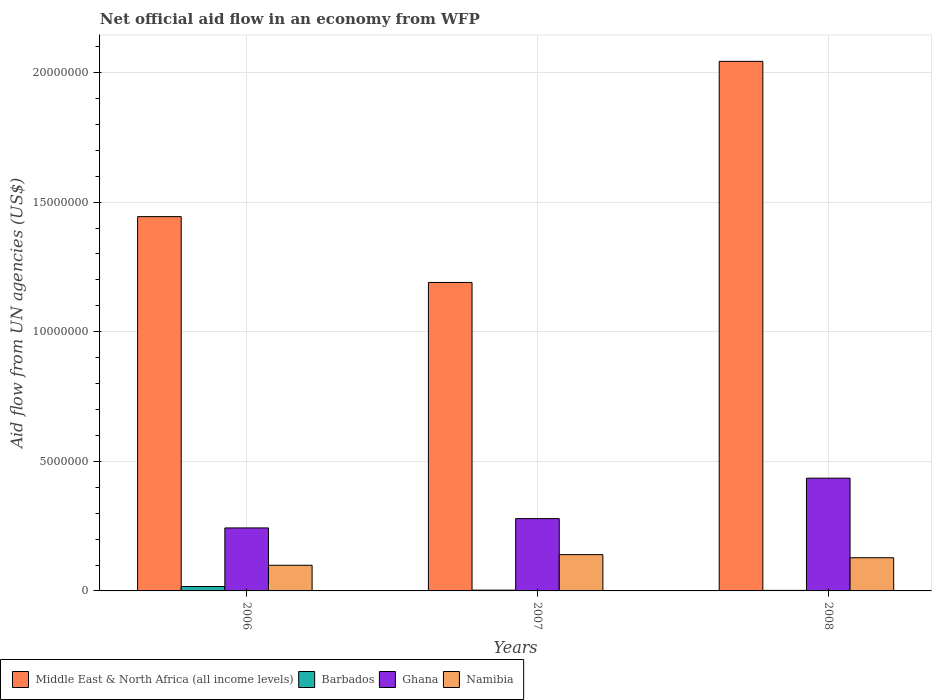How many different coloured bars are there?
Make the answer very short. 4. Are the number of bars per tick equal to the number of legend labels?
Provide a short and direct response. Yes. In how many cases, is the number of bars for a given year not equal to the number of legend labels?
Provide a short and direct response. 0. What is the net official aid flow in Middle East & North Africa (all income levels) in 2006?
Make the answer very short. 1.44e+07. Across all years, what is the maximum net official aid flow in Namibia?
Keep it short and to the point. 1.40e+06. Across all years, what is the minimum net official aid flow in Namibia?
Provide a short and direct response. 9.90e+05. In which year was the net official aid flow in Namibia maximum?
Offer a terse response. 2007. What is the total net official aid flow in Middle East & North Africa (all income levels) in the graph?
Your answer should be very brief. 4.68e+07. What is the difference between the net official aid flow in Namibia in 2007 and the net official aid flow in Middle East & North Africa (all income levels) in 2006?
Your answer should be very brief. -1.30e+07. What is the average net official aid flow in Barbados per year?
Your answer should be very brief. 7.33e+04. In the year 2006, what is the difference between the net official aid flow in Namibia and net official aid flow in Ghana?
Offer a very short reply. -1.44e+06. What is the ratio of the net official aid flow in Middle East & North Africa (all income levels) in 2006 to that in 2007?
Your answer should be compact. 1.21. Is the difference between the net official aid flow in Namibia in 2007 and 2008 greater than the difference between the net official aid flow in Ghana in 2007 and 2008?
Keep it short and to the point. Yes. What is the difference between the highest and the second highest net official aid flow in Ghana?
Your answer should be very brief. 1.56e+06. In how many years, is the net official aid flow in Middle East & North Africa (all income levels) greater than the average net official aid flow in Middle East & North Africa (all income levels) taken over all years?
Ensure brevity in your answer.  1. Is the sum of the net official aid flow in Namibia in 2006 and 2007 greater than the maximum net official aid flow in Barbados across all years?
Offer a very short reply. Yes. Is it the case that in every year, the sum of the net official aid flow in Barbados and net official aid flow in Namibia is greater than the sum of net official aid flow in Middle East & North Africa (all income levels) and net official aid flow in Ghana?
Keep it short and to the point. No. What does the 2nd bar from the left in 2008 represents?
Make the answer very short. Barbados. What does the 1st bar from the right in 2006 represents?
Ensure brevity in your answer.  Namibia. Are all the bars in the graph horizontal?
Ensure brevity in your answer.  No. How many years are there in the graph?
Offer a terse response. 3. What is the difference between two consecutive major ticks on the Y-axis?
Offer a very short reply. 5.00e+06. Are the values on the major ticks of Y-axis written in scientific E-notation?
Make the answer very short. No. Does the graph contain any zero values?
Give a very brief answer. No. Where does the legend appear in the graph?
Your answer should be very brief. Bottom left. How many legend labels are there?
Make the answer very short. 4. How are the legend labels stacked?
Ensure brevity in your answer.  Horizontal. What is the title of the graph?
Make the answer very short. Net official aid flow in an economy from WFP. What is the label or title of the Y-axis?
Keep it short and to the point. Aid flow from UN agencies (US$). What is the Aid flow from UN agencies (US$) in Middle East & North Africa (all income levels) in 2006?
Ensure brevity in your answer.  1.44e+07. What is the Aid flow from UN agencies (US$) in Ghana in 2006?
Provide a short and direct response. 2.43e+06. What is the Aid flow from UN agencies (US$) in Namibia in 2006?
Your answer should be compact. 9.90e+05. What is the Aid flow from UN agencies (US$) of Middle East & North Africa (all income levels) in 2007?
Provide a succinct answer. 1.19e+07. What is the Aid flow from UN agencies (US$) of Barbados in 2007?
Your answer should be very brief. 3.00e+04. What is the Aid flow from UN agencies (US$) of Ghana in 2007?
Offer a very short reply. 2.79e+06. What is the Aid flow from UN agencies (US$) of Namibia in 2007?
Give a very brief answer. 1.40e+06. What is the Aid flow from UN agencies (US$) in Middle East & North Africa (all income levels) in 2008?
Provide a succinct answer. 2.04e+07. What is the Aid flow from UN agencies (US$) in Ghana in 2008?
Your response must be concise. 4.35e+06. What is the Aid flow from UN agencies (US$) in Namibia in 2008?
Keep it short and to the point. 1.28e+06. Across all years, what is the maximum Aid flow from UN agencies (US$) of Middle East & North Africa (all income levels)?
Your answer should be very brief. 2.04e+07. Across all years, what is the maximum Aid flow from UN agencies (US$) of Barbados?
Make the answer very short. 1.70e+05. Across all years, what is the maximum Aid flow from UN agencies (US$) of Ghana?
Make the answer very short. 4.35e+06. Across all years, what is the maximum Aid flow from UN agencies (US$) of Namibia?
Give a very brief answer. 1.40e+06. Across all years, what is the minimum Aid flow from UN agencies (US$) of Middle East & North Africa (all income levels)?
Keep it short and to the point. 1.19e+07. Across all years, what is the minimum Aid flow from UN agencies (US$) in Ghana?
Provide a short and direct response. 2.43e+06. Across all years, what is the minimum Aid flow from UN agencies (US$) in Namibia?
Your answer should be very brief. 9.90e+05. What is the total Aid flow from UN agencies (US$) of Middle East & North Africa (all income levels) in the graph?
Your response must be concise. 4.68e+07. What is the total Aid flow from UN agencies (US$) of Ghana in the graph?
Offer a terse response. 9.57e+06. What is the total Aid flow from UN agencies (US$) of Namibia in the graph?
Provide a succinct answer. 3.67e+06. What is the difference between the Aid flow from UN agencies (US$) in Middle East & North Africa (all income levels) in 2006 and that in 2007?
Your answer should be very brief. 2.54e+06. What is the difference between the Aid flow from UN agencies (US$) in Ghana in 2006 and that in 2007?
Your answer should be compact. -3.60e+05. What is the difference between the Aid flow from UN agencies (US$) of Namibia in 2006 and that in 2007?
Provide a short and direct response. -4.10e+05. What is the difference between the Aid flow from UN agencies (US$) of Middle East & North Africa (all income levels) in 2006 and that in 2008?
Offer a very short reply. -5.99e+06. What is the difference between the Aid flow from UN agencies (US$) of Barbados in 2006 and that in 2008?
Ensure brevity in your answer.  1.50e+05. What is the difference between the Aid flow from UN agencies (US$) in Ghana in 2006 and that in 2008?
Your answer should be compact. -1.92e+06. What is the difference between the Aid flow from UN agencies (US$) in Namibia in 2006 and that in 2008?
Your answer should be very brief. -2.90e+05. What is the difference between the Aid flow from UN agencies (US$) in Middle East & North Africa (all income levels) in 2007 and that in 2008?
Give a very brief answer. -8.53e+06. What is the difference between the Aid flow from UN agencies (US$) of Ghana in 2007 and that in 2008?
Ensure brevity in your answer.  -1.56e+06. What is the difference between the Aid flow from UN agencies (US$) of Middle East & North Africa (all income levels) in 2006 and the Aid flow from UN agencies (US$) of Barbados in 2007?
Offer a very short reply. 1.44e+07. What is the difference between the Aid flow from UN agencies (US$) in Middle East & North Africa (all income levels) in 2006 and the Aid flow from UN agencies (US$) in Ghana in 2007?
Provide a short and direct response. 1.16e+07. What is the difference between the Aid flow from UN agencies (US$) in Middle East & North Africa (all income levels) in 2006 and the Aid flow from UN agencies (US$) in Namibia in 2007?
Ensure brevity in your answer.  1.30e+07. What is the difference between the Aid flow from UN agencies (US$) of Barbados in 2006 and the Aid flow from UN agencies (US$) of Ghana in 2007?
Provide a short and direct response. -2.62e+06. What is the difference between the Aid flow from UN agencies (US$) in Barbados in 2006 and the Aid flow from UN agencies (US$) in Namibia in 2007?
Your answer should be compact. -1.23e+06. What is the difference between the Aid flow from UN agencies (US$) in Ghana in 2006 and the Aid flow from UN agencies (US$) in Namibia in 2007?
Provide a short and direct response. 1.03e+06. What is the difference between the Aid flow from UN agencies (US$) in Middle East & North Africa (all income levels) in 2006 and the Aid flow from UN agencies (US$) in Barbados in 2008?
Offer a terse response. 1.44e+07. What is the difference between the Aid flow from UN agencies (US$) in Middle East & North Africa (all income levels) in 2006 and the Aid flow from UN agencies (US$) in Ghana in 2008?
Ensure brevity in your answer.  1.01e+07. What is the difference between the Aid flow from UN agencies (US$) in Middle East & North Africa (all income levels) in 2006 and the Aid flow from UN agencies (US$) in Namibia in 2008?
Offer a terse response. 1.32e+07. What is the difference between the Aid flow from UN agencies (US$) of Barbados in 2006 and the Aid flow from UN agencies (US$) of Ghana in 2008?
Your answer should be compact. -4.18e+06. What is the difference between the Aid flow from UN agencies (US$) in Barbados in 2006 and the Aid flow from UN agencies (US$) in Namibia in 2008?
Give a very brief answer. -1.11e+06. What is the difference between the Aid flow from UN agencies (US$) in Ghana in 2006 and the Aid flow from UN agencies (US$) in Namibia in 2008?
Keep it short and to the point. 1.15e+06. What is the difference between the Aid flow from UN agencies (US$) in Middle East & North Africa (all income levels) in 2007 and the Aid flow from UN agencies (US$) in Barbados in 2008?
Provide a succinct answer. 1.19e+07. What is the difference between the Aid flow from UN agencies (US$) of Middle East & North Africa (all income levels) in 2007 and the Aid flow from UN agencies (US$) of Ghana in 2008?
Your answer should be compact. 7.55e+06. What is the difference between the Aid flow from UN agencies (US$) of Middle East & North Africa (all income levels) in 2007 and the Aid flow from UN agencies (US$) of Namibia in 2008?
Keep it short and to the point. 1.06e+07. What is the difference between the Aid flow from UN agencies (US$) in Barbados in 2007 and the Aid flow from UN agencies (US$) in Ghana in 2008?
Provide a succinct answer. -4.32e+06. What is the difference between the Aid flow from UN agencies (US$) of Barbados in 2007 and the Aid flow from UN agencies (US$) of Namibia in 2008?
Your answer should be compact. -1.25e+06. What is the difference between the Aid flow from UN agencies (US$) in Ghana in 2007 and the Aid flow from UN agencies (US$) in Namibia in 2008?
Ensure brevity in your answer.  1.51e+06. What is the average Aid flow from UN agencies (US$) in Middle East & North Africa (all income levels) per year?
Keep it short and to the point. 1.56e+07. What is the average Aid flow from UN agencies (US$) in Barbados per year?
Provide a short and direct response. 7.33e+04. What is the average Aid flow from UN agencies (US$) in Ghana per year?
Keep it short and to the point. 3.19e+06. What is the average Aid flow from UN agencies (US$) in Namibia per year?
Give a very brief answer. 1.22e+06. In the year 2006, what is the difference between the Aid flow from UN agencies (US$) in Middle East & North Africa (all income levels) and Aid flow from UN agencies (US$) in Barbados?
Provide a succinct answer. 1.43e+07. In the year 2006, what is the difference between the Aid flow from UN agencies (US$) in Middle East & North Africa (all income levels) and Aid flow from UN agencies (US$) in Ghana?
Offer a terse response. 1.20e+07. In the year 2006, what is the difference between the Aid flow from UN agencies (US$) in Middle East & North Africa (all income levels) and Aid flow from UN agencies (US$) in Namibia?
Make the answer very short. 1.34e+07. In the year 2006, what is the difference between the Aid flow from UN agencies (US$) in Barbados and Aid flow from UN agencies (US$) in Ghana?
Offer a terse response. -2.26e+06. In the year 2006, what is the difference between the Aid flow from UN agencies (US$) in Barbados and Aid flow from UN agencies (US$) in Namibia?
Keep it short and to the point. -8.20e+05. In the year 2006, what is the difference between the Aid flow from UN agencies (US$) in Ghana and Aid flow from UN agencies (US$) in Namibia?
Provide a short and direct response. 1.44e+06. In the year 2007, what is the difference between the Aid flow from UN agencies (US$) of Middle East & North Africa (all income levels) and Aid flow from UN agencies (US$) of Barbados?
Keep it short and to the point. 1.19e+07. In the year 2007, what is the difference between the Aid flow from UN agencies (US$) in Middle East & North Africa (all income levels) and Aid flow from UN agencies (US$) in Ghana?
Provide a short and direct response. 9.11e+06. In the year 2007, what is the difference between the Aid flow from UN agencies (US$) of Middle East & North Africa (all income levels) and Aid flow from UN agencies (US$) of Namibia?
Give a very brief answer. 1.05e+07. In the year 2007, what is the difference between the Aid flow from UN agencies (US$) in Barbados and Aid flow from UN agencies (US$) in Ghana?
Your answer should be compact. -2.76e+06. In the year 2007, what is the difference between the Aid flow from UN agencies (US$) of Barbados and Aid flow from UN agencies (US$) of Namibia?
Make the answer very short. -1.37e+06. In the year 2007, what is the difference between the Aid flow from UN agencies (US$) in Ghana and Aid flow from UN agencies (US$) in Namibia?
Offer a very short reply. 1.39e+06. In the year 2008, what is the difference between the Aid flow from UN agencies (US$) of Middle East & North Africa (all income levels) and Aid flow from UN agencies (US$) of Barbados?
Offer a terse response. 2.04e+07. In the year 2008, what is the difference between the Aid flow from UN agencies (US$) in Middle East & North Africa (all income levels) and Aid flow from UN agencies (US$) in Ghana?
Ensure brevity in your answer.  1.61e+07. In the year 2008, what is the difference between the Aid flow from UN agencies (US$) in Middle East & North Africa (all income levels) and Aid flow from UN agencies (US$) in Namibia?
Your answer should be very brief. 1.92e+07. In the year 2008, what is the difference between the Aid flow from UN agencies (US$) in Barbados and Aid flow from UN agencies (US$) in Ghana?
Offer a terse response. -4.33e+06. In the year 2008, what is the difference between the Aid flow from UN agencies (US$) in Barbados and Aid flow from UN agencies (US$) in Namibia?
Provide a short and direct response. -1.26e+06. In the year 2008, what is the difference between the Aid flow from UN agencies (US$) of Ghana and Aid flow from UN agencies (US$) of Namibia?
Provide a succinct answer. 3.07e+06. What is the ratio of the Aid flow from UN agencies (US$) in Middle East & North Africa (all income levels) in 2006 to that in 2007?
Ensure brevity in your answer.  1.21. What is the ratio of the Aid flow from UN agencies (US$) in Barbados in 2006 to that in 2007?
Offer a very short reply. 5.67. What is the ratio of the Aid flow from UN agencies (US$) of Ghana in 2006 to that in 2007?
Provide a succinct answer. 0.87. What is the ratio of the Aid flow from UN agencies (US$) in Namibia in 2006 to that in 2007?
Offer a terse response. 0.71. What is the ratio of the Aid flow from UN agencies (US$) of Middle East & North Africa (all income levels) in 2006 to that in 2008?
Provide a short and direct response. 0.71. What is the ratio of the Aid flow from UN agencies (US$) in Ghana in 2006 to that in 2008?
Your answer should be compact. 0.56. What is the ratio of the Aid flow from UN agencies (US$) of Namibia in 2006 to that in 2008?
Keep it short and to the point. 0.77. What is the ratio of the Aid flow from UN agencies (US$) in Middle East & North Africa (all income levels) in 2007 to that in 2008?
Ensure brevity in your answer.  0.58. What is the ratio of the Aid flow from UN agencies (US$) in Ghana in 2007 to that in 2008?
Ensure brevity in your answer.  0.64. What is the ratio of the Aid flow from UN agencies (US$) in Namibia in 2007 to that in 2008?
Keep it short and to the point. 1.09. What is the difference between the highest and the second highest Aid flow from UN agencies (US$) of Middle East & North Africa (all income levels)?
Your response must be concise. 5.99e+06. What is the difference between the highest and the second highest Aid flow from UN agencies (US$) in Ghana?
Keep it short and to the point. 1.56e+06. What is the difference between the highest and the second highest Aid flow from UN agencies (US$) in Namibia?
Keep it short and to the point. 1.20e+05. What is the difference between the highest and the lowest Aid flow from UN agencies (US$) of Middle East & North Africa (all income levels)?
Make the answer very short. 8.53e+06. What is the difference between the highest and the lowest Aid flow from UN agencies (US$) of Barbados?
Your response must be concise. 1.50e+05. What is the difference between the highest and the lowest Aid flow from UN agencies (US$) in Ghana?
Your answer should be very brief. 1.92e+06. 